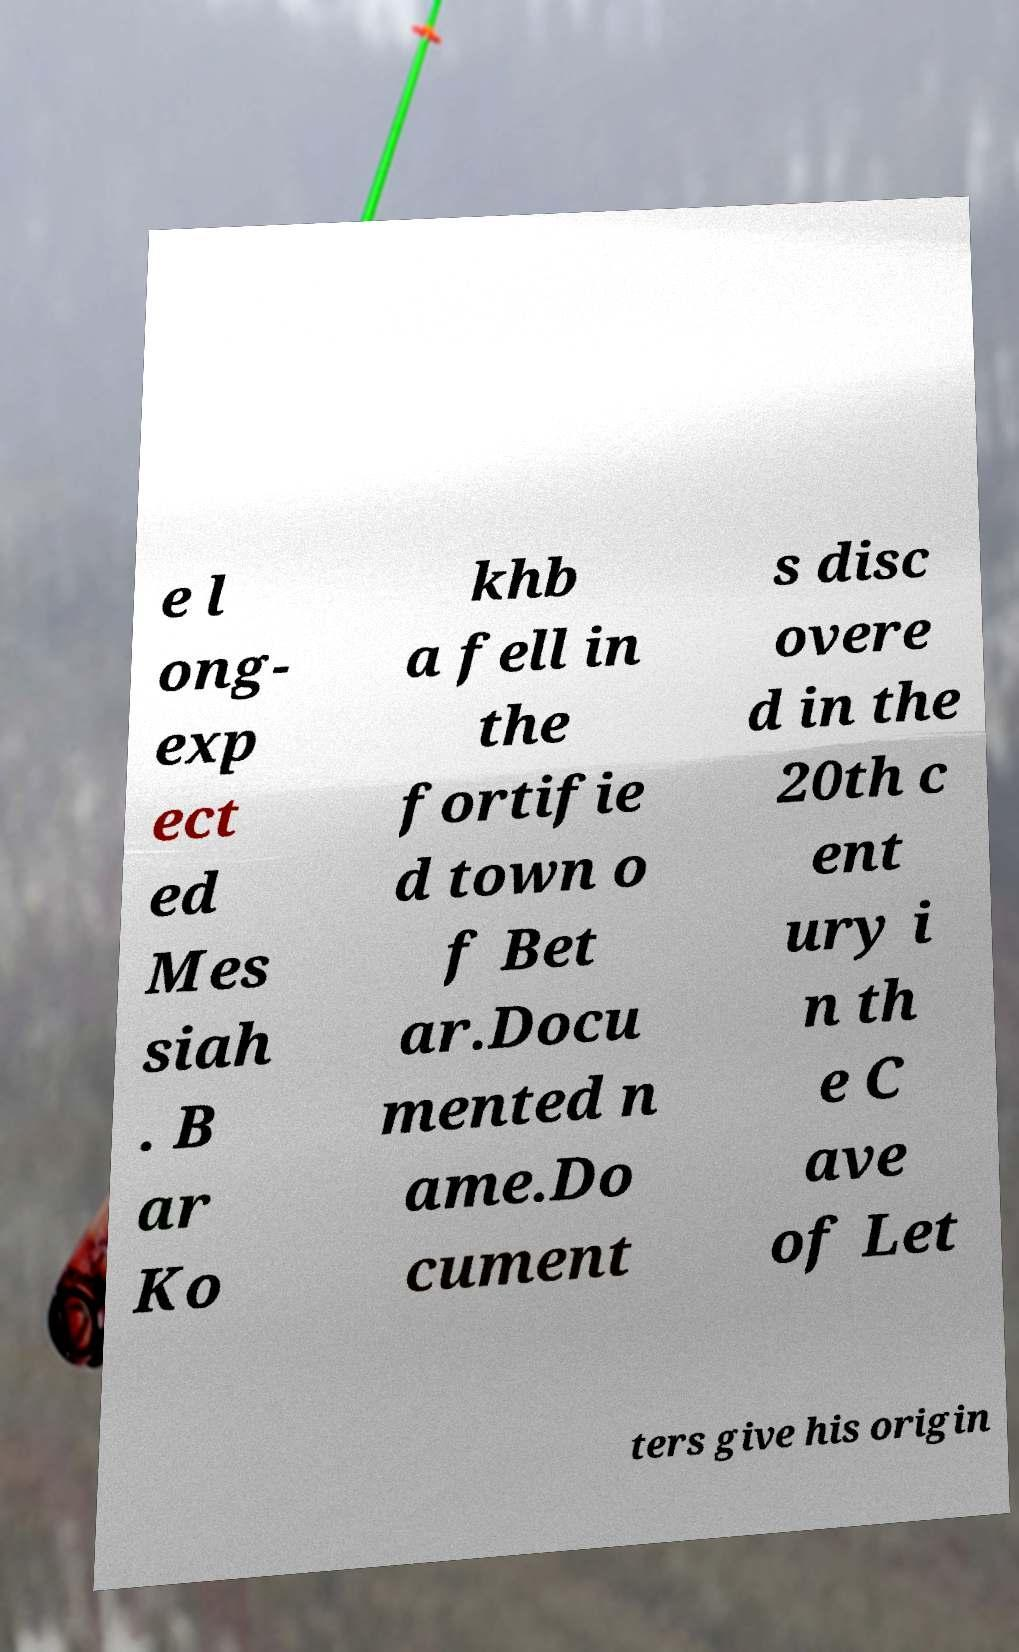Please read and relay the text visible in this image. What does it say? e l ong- exp ect ed Mes siah . B ar Ko khb a fell in the fortifie d town o f Bet ar.Docu mented n ame.Do cument s disc overe d in the 20th c ent ury i n th e C ave of Let ters give his origin 